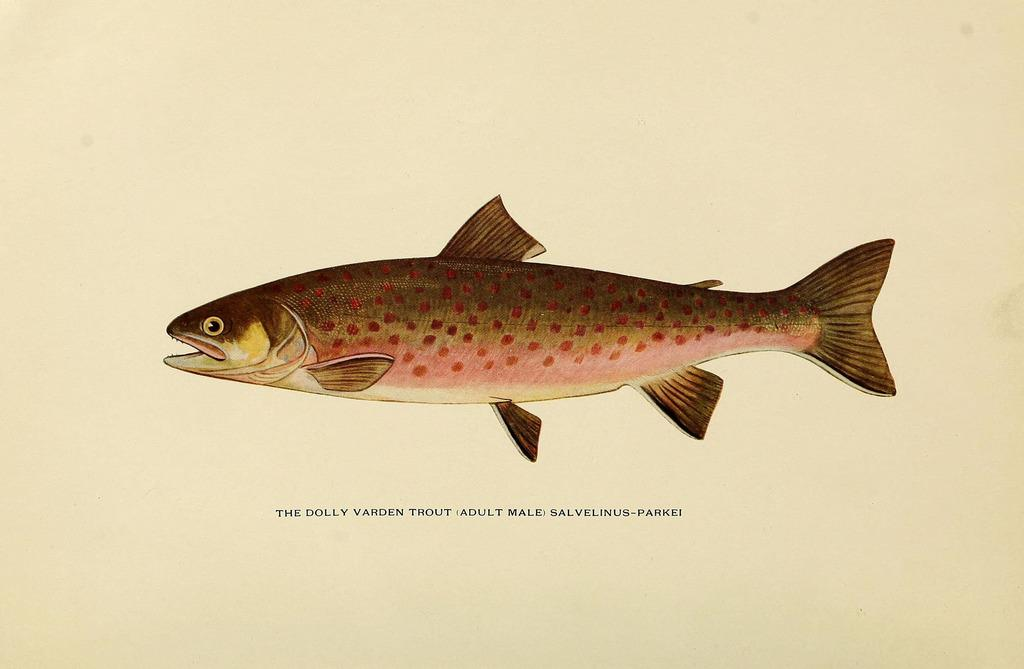What type of animals can be seen in the image? There are fish in the image. What else is present in the image besides the fish? There is text visible in the image. How does the goose feel about the text in the image? There is no goose present in the image, so it cannot be determined how a goose might feel about the text. 